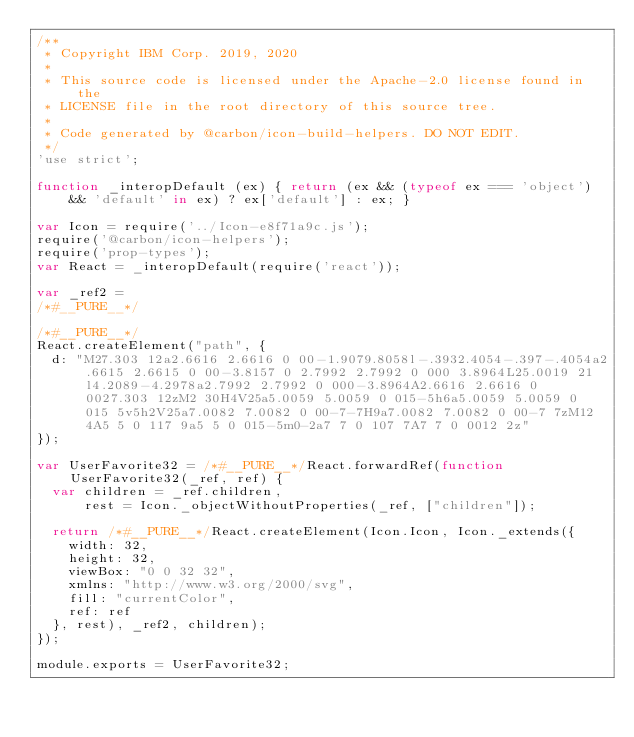Convert code to text. <code><loc_0><loc_0><loc_500><loc_500><_JavaScript_>/**
 * Copyright IBM Corp. 2019, 2020
 *
 * This source code is licensed under the Apache-2.0 license found in the
 * LICENSE file in the root directory of this source tree.
 *
 * Code generated by @carbon/icon-build-helpers. DO NOT EDIT.
 */
'use strict';

function _interopDefault (ex) { return (ex && (typeof ex === 'object') && 'default' in ex) ? ex['default'] : ex; }

var Icon = require('../Icon-e8f71a9c.js');
require('@carbon/icon-helpers');
require('prop-types');
var React = _interopDefault(require('react'));

var _ref2 =
/*#__PURE__*/

/*#__PURE__*/
React.createElement("path", {
  d: "M27.303 12a2.6616 2.6616 0 00-1.9079.8058l-.3932.4054-.397-.4054a2.6615 2.6615 0 00-3.8157 0 2.7992 2.7992 0 000 3.8964L25.0019 21l4.2089-4.2978a2.7992 2.7992 0 000-3.8964A2.6616 2.6616 0 0027.303 12zM2 30H4V25a5.0059 5.0059 0 015-5h6a5.0059 5.0059 0 015 5v5h2V25a7.0082 7.0082 0 00-7-7H9a7.0082 7.0082 0 00-7 7zM12 4A5 5 0 117 9a5 5 0 015-5m0-2a7 7 0 107 7A7 7 0 0012 2z"
});

var UserFavorite32 = /*#__PURE__*/React.forwardRef(function UserFavorite32(_ref, ref) {
  var children = _ref.children,
      rest = Icon._objectWithoutProperties(_ref, ["children"]);

  return /*#__PURE__*/React.createElement(Icon.Icon, Icon._extends({
    width: 32,
    height: 32,
    viewBox: "0 0 32 32",
    xmlns: "http://www.w3.org/2000/svg",
    fill: "currentColor",
    ref: ref
  }, rest), _ref2, children);
});

module.exports = UserFavorite32;
</code> 